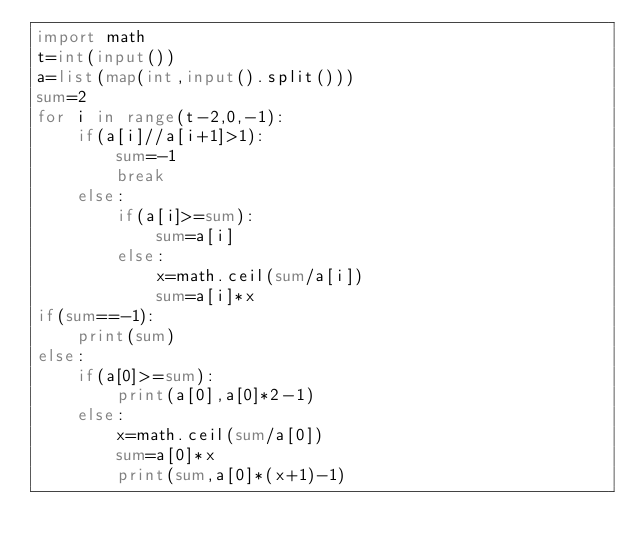<code> <loc_0><loc_0><loc_500><loc_500><_Python_>import math
t=int(input())
a=list(map(int,input().split()))
sum=2
for i in range(t-2,0,-1):
	if(a[i]//a[i+1]>1):
		sum=-1
		break
	else:
		if(a[i]>=sum):
			sum=a[i]
		else:
			x=math.ceil(sum/a[i])
			sum=a[i]*x		
if(sum==-1):					
	print(sum)
else:
	if(a[0]>=sum):
		print(a[0],a[0]*2-1)
	else:
		x=math.ceil(sum/a[0])
		sum=a[0]*x
		print(sum,a[0]*(x+1)-1)			</code> 